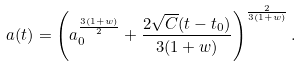<formula> <loc_0><loc_0><loc_500><loc_500>a ( t ) = \left ( a _ { 0 } ^ { \frac { 3 ( 1 + w ) } { 2 } } + \frac { 2 \sqrt { C } ( t - t _ { 0 } ) } { 3 ( 1 + w ) } \right ) ^ { \frac { 2 } { 3 ( 1 + w ) } } .</formula> 